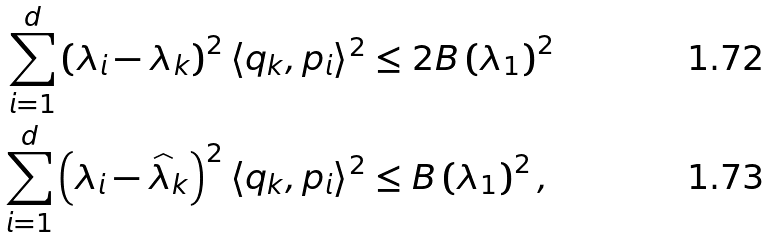<formula> <loc_0><loc_0><loc_500><loc_500>\sum _ { i = 1 } ^ { d } \left ( \lambda _ { i } - \lambda _ { k } \right ) ^ { 2 } \langle q _ { k } , p _ { i } \rangle ^ { 2 } & \leq 2 B \left ( \lambda _ { 1 } \right ) ^ { 2 } \\ \sum _ { i = 1 } ^ { d } \left ( \lambda _ { i } - \widehat { \lambda } _ { k } \right ) ^ { 2 } \langle q _ { k } , p _ { i } \rangle ^ { 2 } & \leq B \left ( \lambda _ { 1 } \right ) ^ { 2 } ,</formula> 